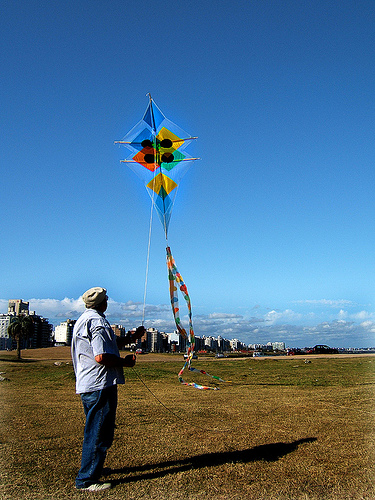What's the setting of the place where the kite is being flown? The location appears to be an open, grassy field, providing plenty of space for kite flying. The sky is clear with few clouds, suggesting good weather for such an outdoor activity. In the background, there are buildings that might be part of a nearby city, giving an urban park vibe to the setting. 